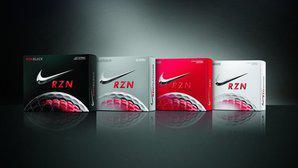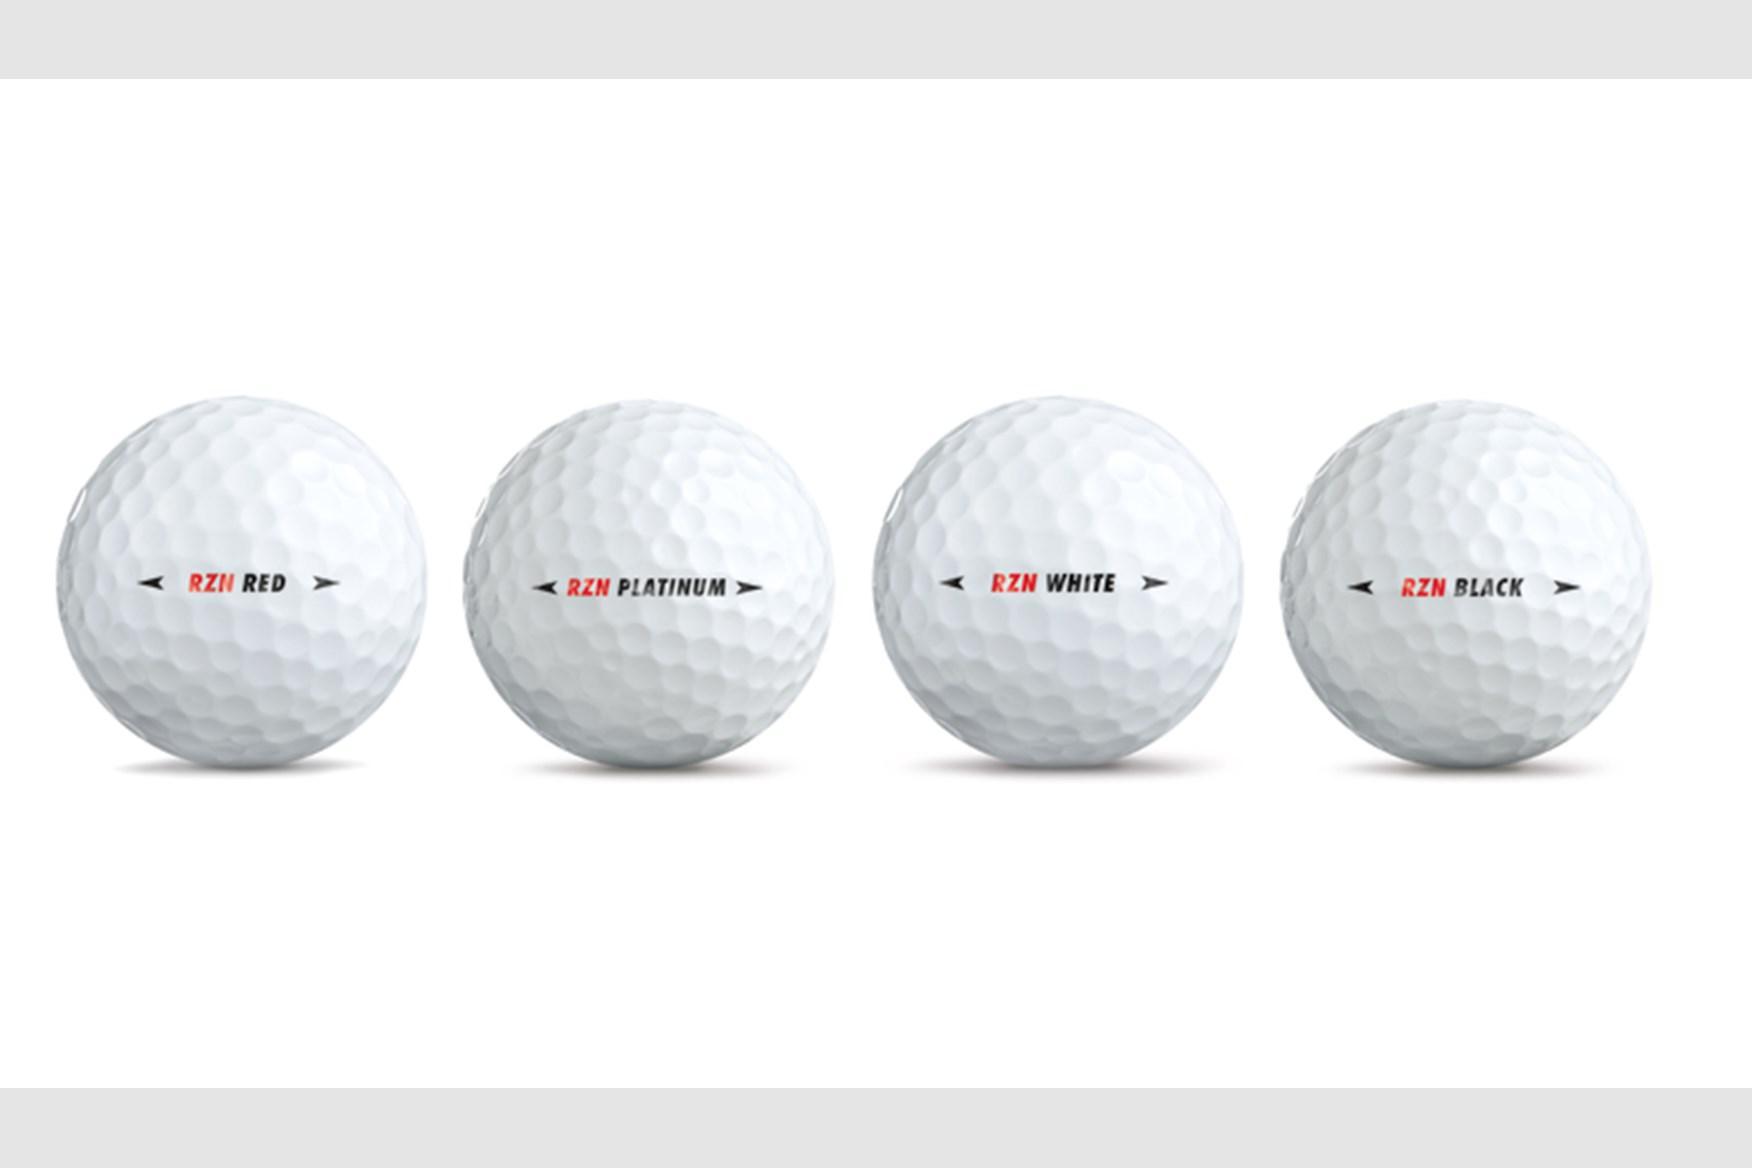The first image is the image on the left, the second image is the image on the right. Evaluate the accuracy of this statement regarding the images: "In at least one image there are two black boxes that have silver and red on them.". Is it true? Answer yes or no. No. The first image is the image on the left, the second image is the image on the right. Assess this claim about the two images: "There are exactly three golf balls that aren't in a box.". Correct or not? Answer yes or no. No. 